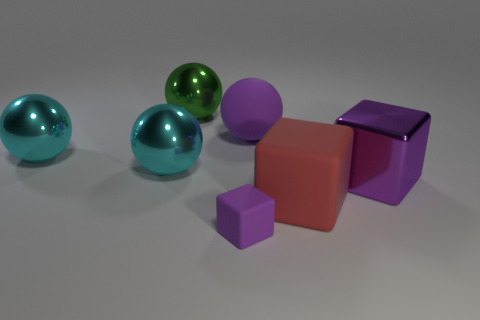Are there any other big balls that have the same material as the green sphere?
Your answer should be very brief. Yes. The large matte block has what color?
Your answer should be compact. Red. What size is the purple object to the right of the big cube that is on the left side of the large metal thing that is on the right side of the green thing?
Ensure brevity in your answer.  Large. How many other things are there of the same shape as the small purple matte object?
Offer a terse response. 2. What is the color of the matte thing that is behind the small purple rubber cube and in front of the matte sphere?
Ensure brevity in your answer.  Red. Is there anything else that has the same size as the purple rubber cube?
Give a very brief answer. No. There is a large rubber object behind the purple metallic thing; is it the same color as the tiny matte object?
Your answer should be very brief. Yes. What number of cylinders are big cyan objects or big green things?
Provide a succinct answer. 0. There is a metal thing that is to the right of the tiny block; what is its shape?
Your answer should be very brief. Cube. What is the color of the metal thing that is to the right of the big shiny object behind the large sphere on the right side of the green ball?
Your response must be concise. Purple. 